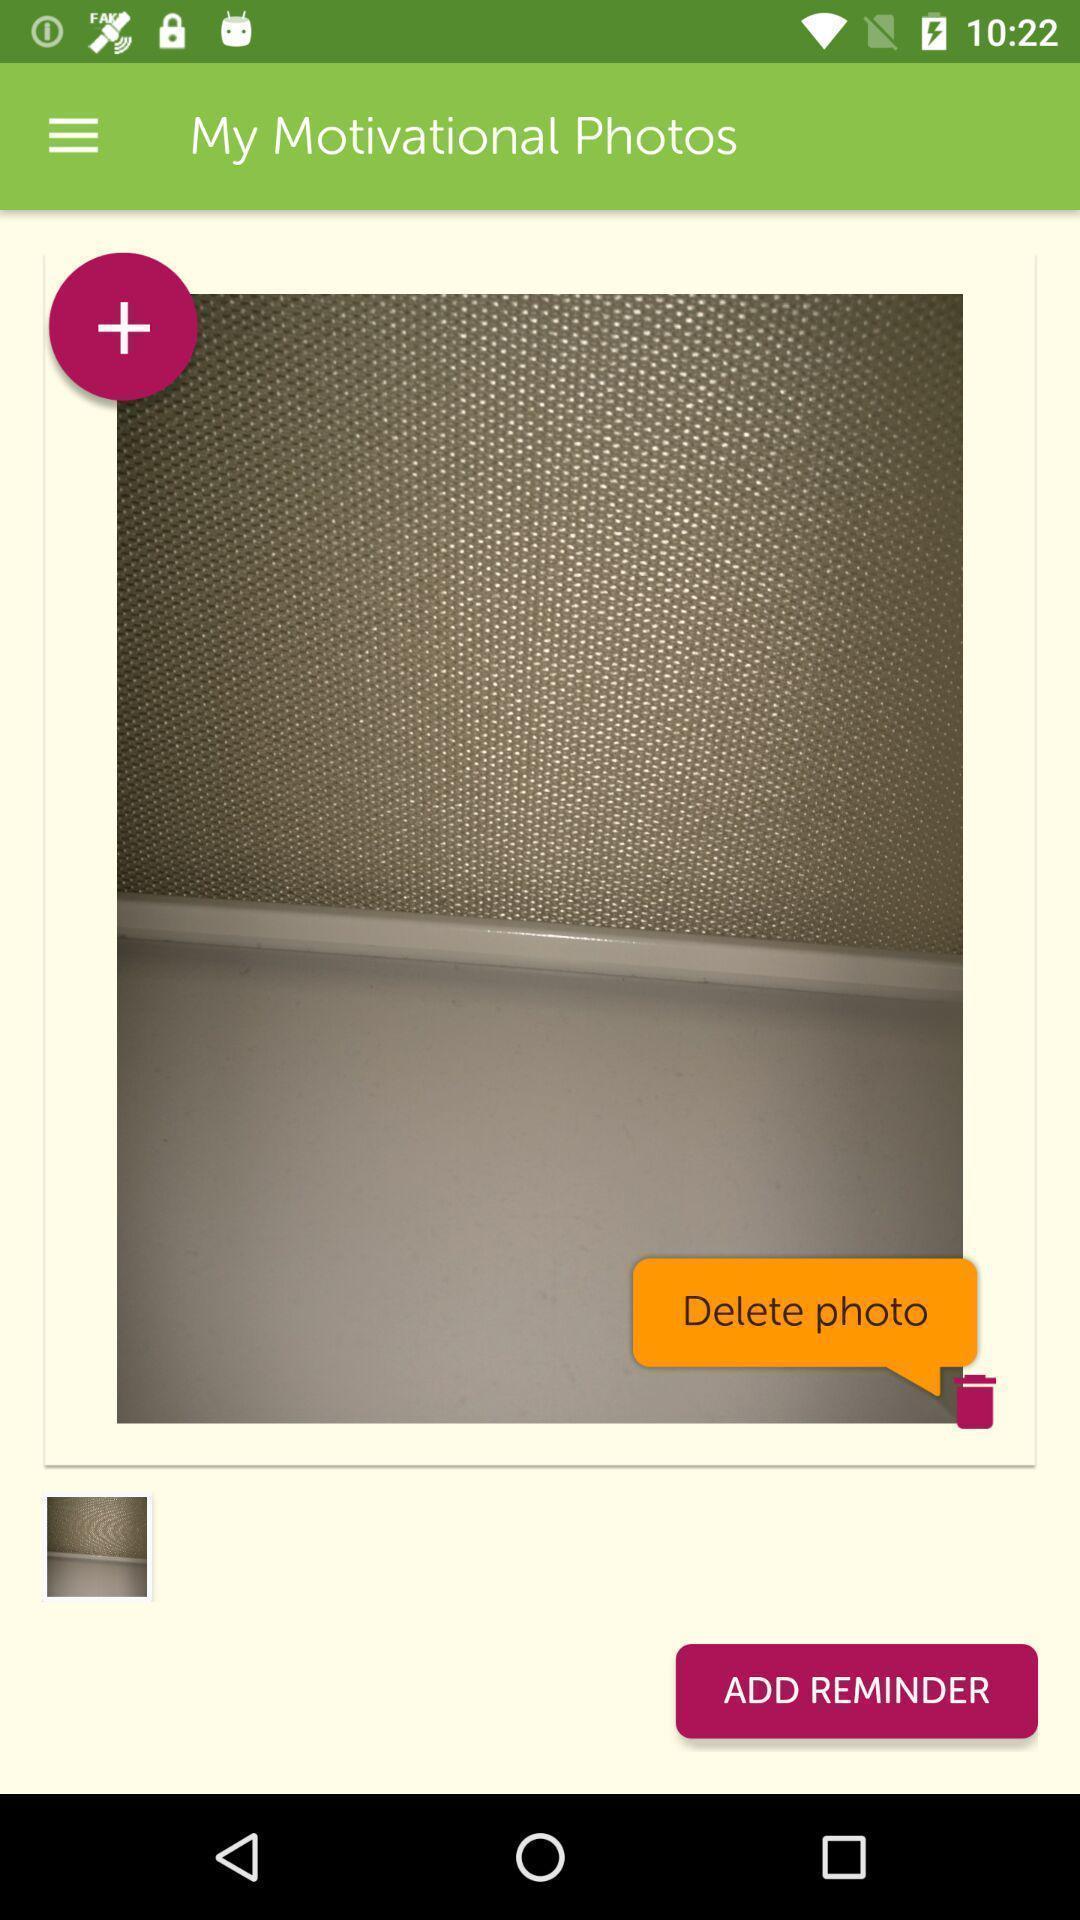Give me a summary of this screen capture. Screen shows motivational photos page with delete and add options. 